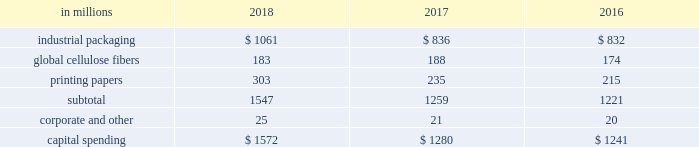The company recorded equity earnings , net of taxes , related to ilim of $ 290 million in 2018 , compared with earnings of $ 183 million in 2017 , and $ 199 million in 2016 .
Operating results recorded in 2018 included an after-tax non-cash foreign exchange loss of $ 82 million , compared with an after-tax foreign exchange gain of $ 15 million in 2017 and an after-tax foreign exchange gain of $ 25 million in 2016 , primarily on the remeasurement of ilim's u.s .
Dollar denominated net debt .
Ilim delivered outstanding performance in 2018 , driven largely by higher price realization and strong demand .
Sales volumes for the joint venture increased year over year for shipments to china of softwood pulp and linerboard , but were offset by decreased sales of hardwood pulp to china .
Sales volumes in the russian market increased for softwood pulp and hardwood pulp , but decreased for linerboard .
Average sales price realizations were significantly higher in 2018 for sales of softwood pulp , hardwood pulp and linerboard to china and other export markets .
Average sales price realizations in russian markets increased year over year for all products .
Input costs were higher in 2018 , primarily for wood , fuel and chemicals .
Distribution costs were negatively impacted by tariffs and inflation .
The company received cash dividends from the joint venture of $ 128 million in 2018 , $ 133 million in 2017 and $ 58 million in entering the first quarter of 2019 , sales volumes are expected to be lower than in the fourth quarter of 2018 , due to the seasonal slowdown in china and fewer trading days .
Based on pricing to date in the current quarter , average sales prices are expected to decrease for hardwood pulp , softwood pulp and linerboard to china .
Input costs are projected to be relatively flat , while distribution costs are expected to increase .
Equity earnings - gpip international paper recorded equity earnings of $ 46 million on its 20.5% ( 20.5 % ) ownership position in gpip in 2018 .
The company received cash dividends from the investment of $ 25 million in 2018 .
Liquidity and capital resources overview a major factor in international paper 2019s liquidity and capital resource planning is its generation of operating cash flow , which is highly sensitive to changes in the pricing and demand for our major products .
While changes in key cash operating costs , such as energy , raw material , mill outage and transportation costs , do have an effect on operating cash generation , we believe that our focus on pricing and cost controls has improved our cash flow generation over an operating cycle .
Cash uses during 2018 were primarily focused on working capital requirements , capital spending , debt reductions and returning cash to shareholders through dividends and share repurchases under the company's share repurchase program .
Cash provided by operating activities cash provided by operations , including discontinued operations , totaled $ 3.2 billion in 2018 , compared with $ 1.8 billion for 2017 , and $ 2.5 billion for 2016 .
Cash used by working capital components ( accounts receivable , contract assets and inventory less accounts payable and accrued liabilities , interest payable and other ) totaled $ 439 million in 2018 , compared with cash used by working capital components of $ 402 million in 2017 , and cash provided by working capital components of $ 71 million in 2016 .
Investment activities including discontinued operations , investment activities in 2018 increased from 2017 , as 2018 included higher capital spending .
In 2016 , investment activity included the purchase of weyerhaeuser's pulp business for $ 2.2 billion in cash , the purchase of the holmen business for $ 57 million in cash , net of cash acquired , and proceeds from the sale of the asia packaging business of $ 108 million , net of cash divested .
The company maintains an average capital spending target around depreciation and amortization levels , or modestly above , due to strategic plans over the course of an economic cycle .
Capital spending was $ 1.6 billion in 2018 , or 118% ( 118 % ) of depreciation and amortization , compared with $ 1.4 billion in 2017 , or 98% ( 98 % ) of depreciation and amortization , and $ 1.3 billion , or 110% ( 110 % ) of depreciation and amortization in 2016 .
Across our segments , capital spending as a percentage of depreciation and amortization ranged from 69.8% ( 69.8 % ) to 132.1% ( 132.1 % ) in 2018 .
The table shows capital spending for operations by business segment for the years ended december 31 , 2018 , 2017 and 2016 , excluding amounts related to discontinued operations of $ 111 million in 2017 and $ 107 million in 2016. .
Capital expenditures in 2019 are currently expected to be about $ 1.4 billion , or 104% ( 104 % ) of depreciation and amortization , including approximately $ 400 million of strategic investments. .
What is the growth observed in the industrial packaging segment , during 2017 and 2018? 
Rationale: it is the value of 2018 divided by the 2017's , then turned into a percentage to represent the increase .
Computations: ((1061 / 836) - 1)
Answer: 0.26914. 